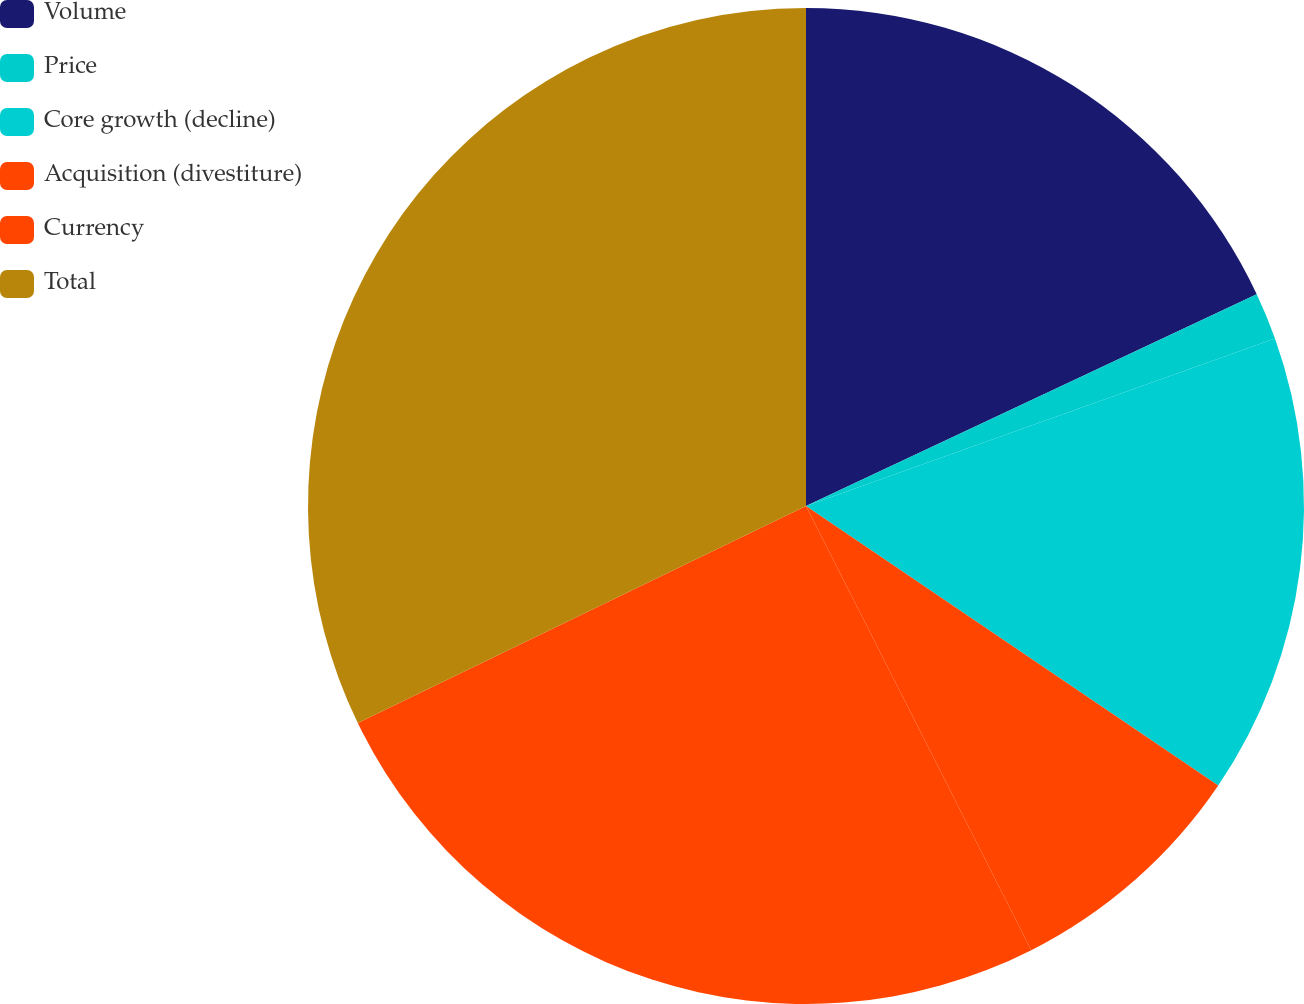Convert chart to OTSL. <chart><loc_0><loc_0><loc_500><loc_500><pie_chart><fcel>Volume<fcel>Price<fcel>Core growth (decline)<fcel>Acquisition (divestiture)<fcel>Currency<fcel>Total<nl><fcel>18.01%<fcel>1.53%<fcel>14.94%<fcel>8.05%<fcel>25.29%<fcel>32.18%<nl></chart> 